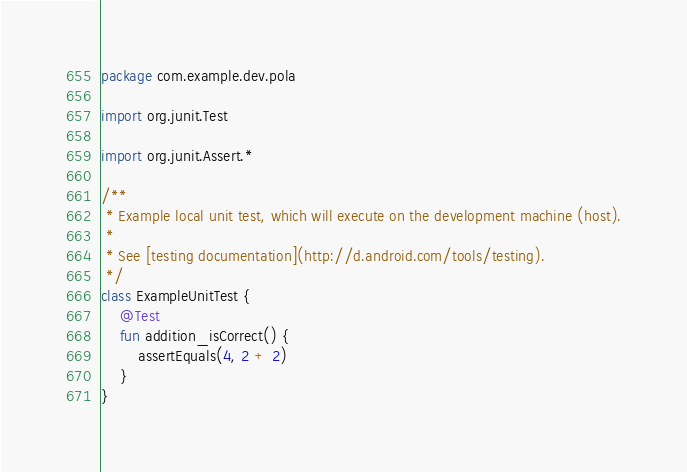<code> <loc_0><loc_0><loc_500><loc_500><_Kotlin_>package com.example.dev.pola

import org.junit.Test

import org.junit.Assert.*

/**
 * Example local unit test, which will execute on the development machine (host).
 *
 * See [testing documentation](http://d.android.com/tools/testing).
 */
class ExampleUnitTest {
    @Test
    fun addition_isCorrect() {
        assertEquals(4, 2 + 2)
    }
}
</code> 